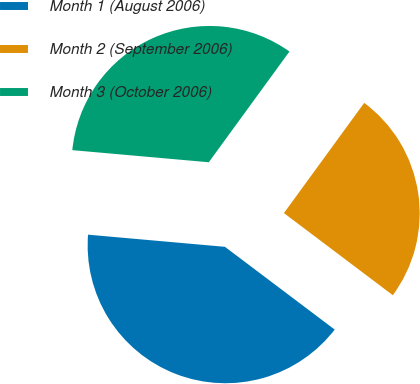Convert chart to OTSL. <chart><loc_0><loc_0><loc_500><loc_500><pie_chart><fcel>Month 1 (August 2006)<fcel>Month 2 (September 2006)<fcel>Month 3 (October 2006)<nl><fcel>41.12%<fcel>25.26%<fcel>33.61%<nl></chart> 